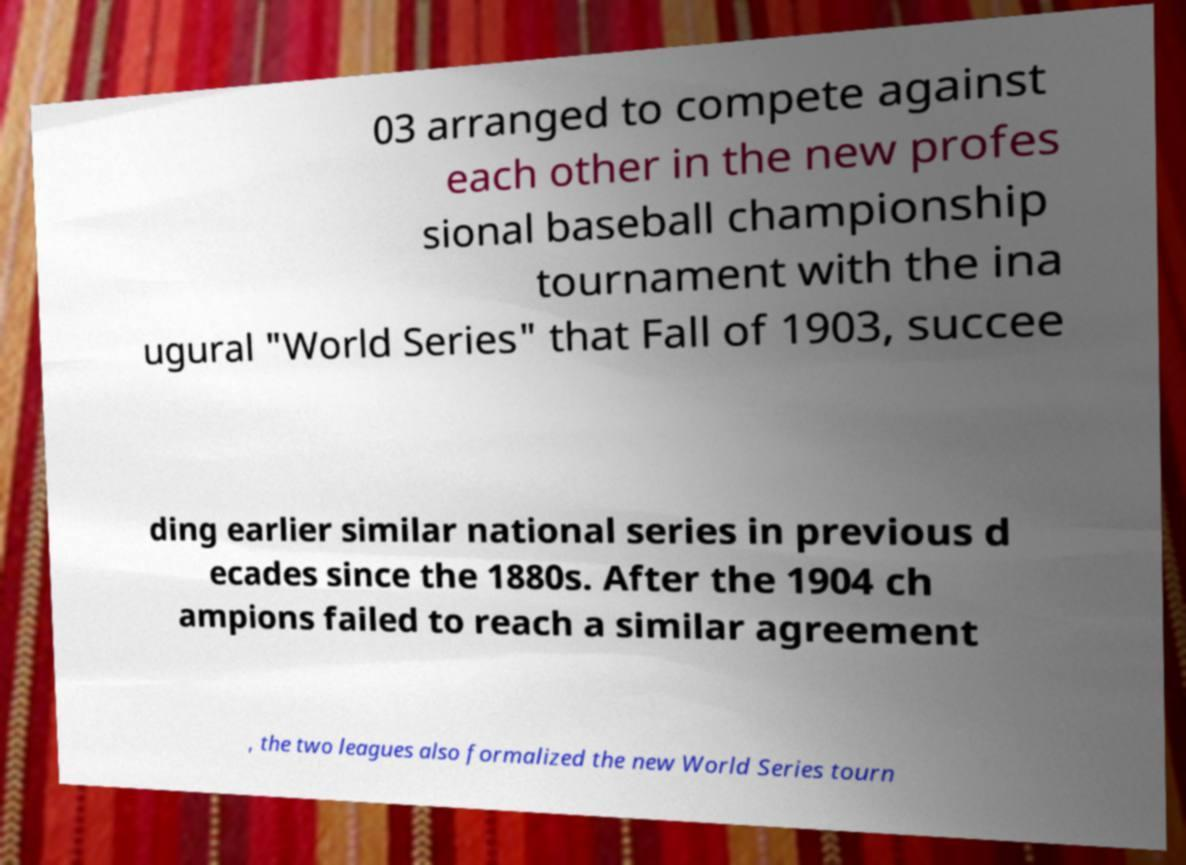Please read and relay the text visible in this image. What does it say? 03 arranged to compete against each other in the new profes sional baseball championship tournament with the ina ugural "World Series" that Fall of 1903, succee ding earlier similar national series in previous d ecades since the 1880s. After the 1904 ch ampions failed to reach a similar agreement , the two leagues also formalized the new World Series tourn 